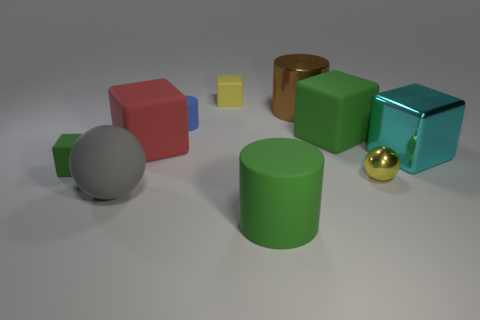What is the material of the thing that is the same color as the small ball?
Give a very brief answer. Rubber. How many things are either metal things that are left of the big cyan cube or green cubes?
Offer a very short reply. 4. There is a large ball that is the same material as the small yellow block; what color is it?
Give a very brief answer. Gray. Are there any blue blocks that have the same size as the metal sphere?
Give a very brief answer. No. How many things are either large blocks that are behind the big cyan shiny block or small matte blocks left of the large red matte cube?
Make the answer very short. 3. What shape is the cyan shiny object that is the same size as the gray ball?
Your answer should be compact. Cube. Are there any big objects that have the same shape as the small yellow metal object?
Ensure brevity in your answer.  Yes. Are there fewer cyan things than large gray matte blocks?
Your response must be concise. No. There is a matte cylinder in front of the large green cube; does it have the same size as the matte cylinder behind the big gray rubber object?
Your response must be concise. No. How many objects are either tiny green rubber blocks or yellow rubber blocks?
Give a very brief answer. 2. 